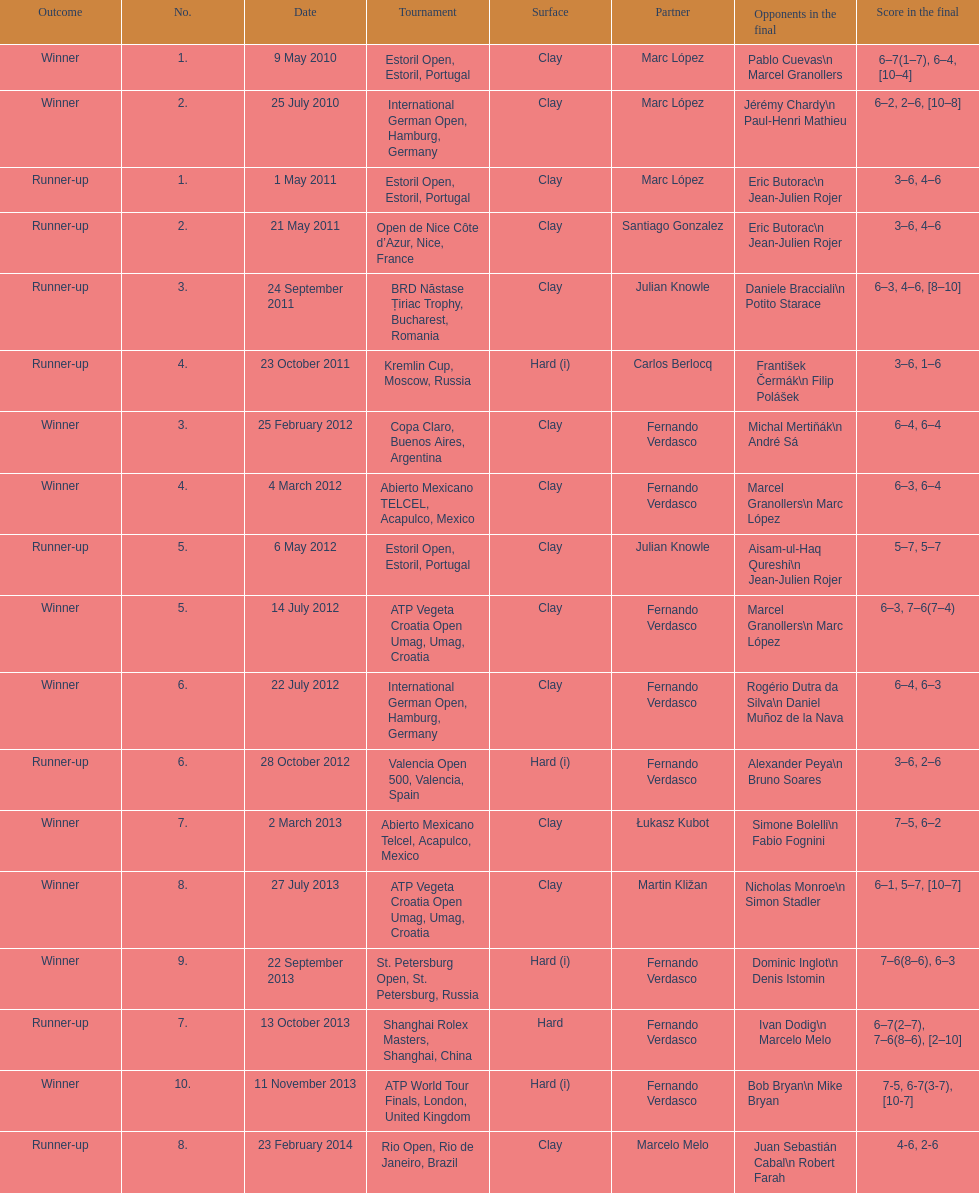What tournament was played after the kremlin cup? Copa Claro, Buenos Aires, Argentina. 